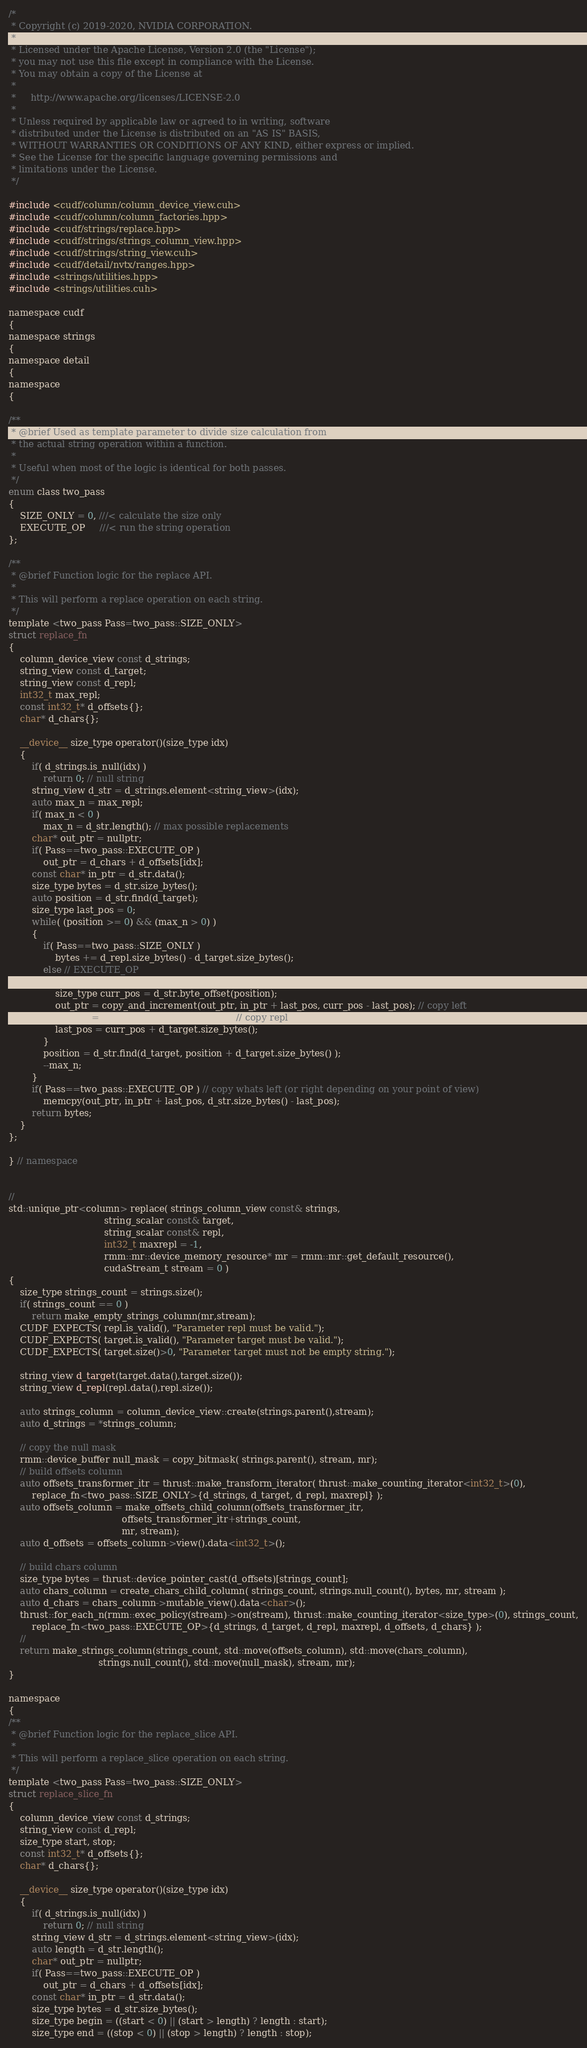<code> <loc_0><loc_0><loc_500><loc_500><_Cuda_>/*
 * Copyright (c) 2019-2020, NVIDIA CORPORATION.
 *
 * Licensed under the Apache License, Version 2.0 (the "License");
 * you may not use this file except in compliance with the License.
 * You may obtain a copy of the License at
 *
 *     http://www.apache.org/licenses/LICENSE-2.0
 *
 * Unless required by applicable law or agreed to in writing, software
 * distributed under the License is distributed on an "AS IS" BASIS,
 * WITHOUT WARRANTIES OR CONDITIONS OF ANY KIND, either express or implied.
 * See the License for the specific language governing permissions and
 * limitations under the License.
 */

#include <cudf/column/column_device_view.cuh>
#include <cudf/column/column_factories.hpp>
#include <cudf/strings/replace.hpp>
#include <cudf/strings/strings_column_view.hpp>
#include <cudf/strings/string_view.cuh>
#include <cudf/detail/nvtx/ranges.hpp>
#include <strings/utilities.hpp>
#include <strings/utilities.cuh>

namespace cudf
{
namespace strings
{
namespace detail
{
namespace
{

/**
 * @brief Used as template parameter to divide size calculation from
 * the actual string operation within a function.
 *
 * Useful when most of the logic is identical for both passes.
 */
enum class two_pass
{
    SIZE_ONLY = 0, ///< calculate the size only
    EXECUTE_OP     ///< run the string operation
};

/**
 * @brief Function logic for the replace API.
 *
 * This will perform a replace operation on each string.
 */
template <two_pass Pass=two_pass::SIZE_ONLY>
struct replace_fn
{
    column_device_view const d_strings;
    string_view const d_target;
    string_view const d_repl;
    int32_t max_repl;
    const int32_t* d_offsets{};
    char* d_chars{};

    __device__ size_type operator()(size_type idx)
    {
        if( d_strings.is_null(idx) )
            return 0; // null string
        string_view d_str = d_strings.element<string_view>(idx);
        auto max_n = max_repl;
        if( max_n < 0 )
            max_n = d_str.length(); // max possible replacements
        char* out_ptr = nullptr;
        if( Pass==two_pass::EXECUTE_OP )
            out_ptr = d_chars + d_offsets[idx];
        const char* in_ptr = d_str.data();
        size_type bytes = d_str.size_bytes();
        auto position = d_str.find(d_target);
        size_type last_pos = 0;
        while( (position >= 0) && (max_n > 0) )
        {
            if( Pass==two_pass::SIZE_ONLY )
                bytes += d_repl.size_bytes() - d_target.size_bytes();
            else // EXECUTE_OP
            {
                size_type curr_pos = d_str.byte_offset(position);
                out_ptr = copy_and_increment(out_ptr, in_ptr + last_pos, curr_pos - last_pos); // copy left
                out_ptr = copy_string(out_ptr, d_repl); // copy repl
                last_pos = curr_pos + d_target.size_bytes();
            }
            position = d_str.find(d_target, position + d_target.size_bytes() );
            --max_n;
        }
        if( Pass==two_pass::EXECUTE_OP ) // copy whats left (or right depending on your point of view)
            memcpy(out_ptr, in_ptr + last_pos, d_str.size_bytes() - last_pos);
        return bytes;
    }
};

} // namespace


//
std::unique_ptr<column> replace( strings_column_view const& strings,
                                 string_scalar const& target,
                                 string_scalar const& repl,
                                 int32_t maxrepl = -1,
                                 rmm::mr::device_memory_resource* mr = rmm::mr::get_default_resource(),
                                 cudaStream_t stream = 0 )
{
    size_type strings_count = strings.size();
    if( strings_count == 0 )
        return make_empty_strings_column(mr,stream);
    CUDF_EXPECTS( repl.is_valid(), "Parameter repl must be valid.");
    CUDF_EXPECTS( target.is_valid(), "Parameter target must be valid.");
    CUDF_EXPECTS( target.size()>0, "Parameter target must not be empty string.");

    string_view d_target(target.data(),target.size());
    string_view d_repl(repl.data(),repl.size());

    auto strings_column = column_device_view::create(strings.parent(),stream);
    auto d_strings = *strings_column;

    // copy the null mask
    rmm::device_buffer null_mask = copy_bitmask( strings.parent(), stream, mr);
    // build offsets column
    auto offsets_transformer_itr = thrust::make_transform_iterator( thrust::make_counting_iterator<int32_t>(0),
        replace_fn<two_pass::SIZE_ONLY>{d_strings, d_target, d_repl, maxrepl} );
    auto offsets_column = make_offsets_child_column(offsets_transformer_itr,
                                       offsets_transformer_itr+strings_count,
                                       mr, stream);
    auto d_offsets = offsets_column->view().data<int32_t>();

    // build chars column
    size_type bytes = thrust::device_pointer_cast(d_offsets)[strings_count];
    auto chars_column = create_chars_child_column( strings_count, strings.null_count(), bytes, mr, stream );
    auto d_chars = chars_column->mutable_view().data<char>();
    thrust::for_each_n(rmm::exec_policy(stream)->on(stream), thrust::make_counting_iterator<size_type>(0), strings_count,
        replace_fn<two_pass::EXECUTE_OP>{d_strings, d_target, d_repl, maxrepl, d_offsets, d_chars} );
    //
    return make_strings_column(strings_count, std::move(offsets_column), std::move(chars_column),
                               strings.null_count(), std::move(null_mask), stream, mr);
}

namespace
{
/**
 * @brief Function logic for the replace_slice API.
 *
 * This will perform a replace_slice operation on each string.
 */
template <two_pass Pass=two_pass::SIZE_ONLY>
struct replace_slice_fn
{
    column_device_view const d_strings;
    string_view const d_repl;
    size_type start, stop;
    const int32_t* d_offsets{};
    char* d_chars{};

    __device__ size_type operator()(size_type idx)
    {
        if( d_strings.is_null(idx) )
            return 0; // null string
        string_view d_str = d_strings.element<string_view>(idx);
        auto length = d_str.length();
        char* out_ptr = nullptr;
        if( Pass==two_pass::EXECUTE_OP )
            out_ptr = d_chars + d_offsets[idx];
        const char* in_ptr = d_str.data();
        size_type bytes = d_str.size_bytes();
        size_type begin = ((start < 0) || (start > length) ? length : start);
        size_type end = ((stop < 0) || (stop > length) ? length : stop);</code> 